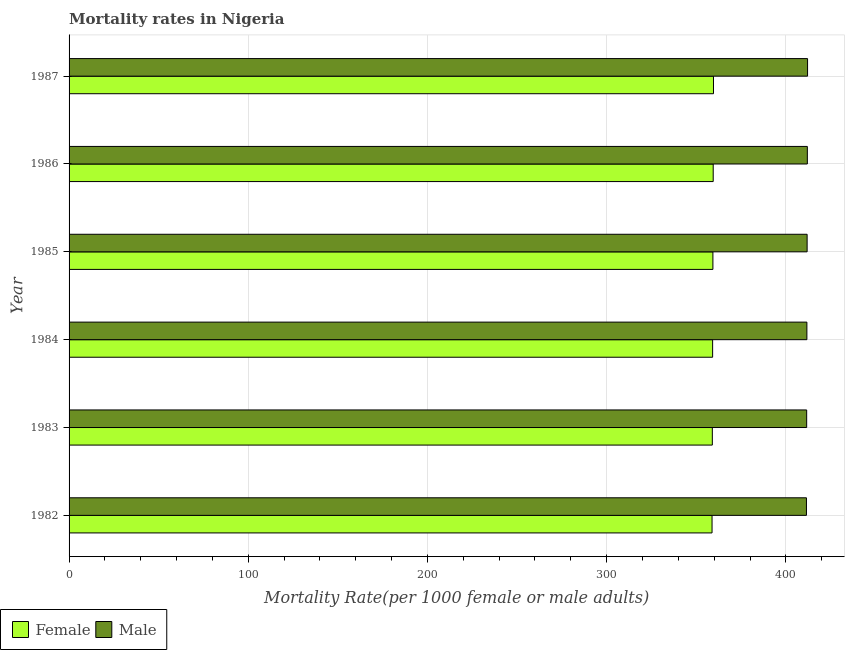How many groups of bars are there?
Keep it short and to the point. 6. Are the number of bars on each tick of the Y-axis equal?
Your response must be concise. Yes. How many bars are there on the 3rd tick from the bottom?
Ensure brevity in your answer.  2. What is the label of the 6th group of bars from the top?
Offer a terse response. 1982. In how many cases, is the number of bars for a given year not equal to the number of legend labels?
Your answer should be compact. 0. What is the female mortality rate in 1984?
Give a very brief answer. 359.14. Across all years, what is the maximum male mortality rate?
Give a very brief answer. 412.12. Across all years, what is the minimum female mortality rate?
Your answer should be very brief. 358.82. What is the total male mortality rate in the graph?
Provide a succinct answer. 2470.87. What is the difference between the male mortality rate in 1982 and that in 1983?
Make the answer very short. -0.12. What is the difference between the male mortality rate in 1985 and the female mortality rate in 1986?
Your response must be concise. 52.41. What is the average male mortality rate per year?
Provide a short and direct response. 411.81. In the year 1985, what is the difference between the female mortality rate and male mortality rate?
Make the answer very short. -52.58. In how many years, is the male mortality rate greater than 380 ?
Keep it short and to the point. 6. What is the ratio of the male mortality rate in 1982 to that in 1987?
Make the answer very short. 1. Is the female mortality rate in 1982 less than that in 1986?
Offer a terse response. Yes. Is the difference between the female mortality rate in 1985 and 1986 greater than the difference between the male mortality rate in 1985 and 1986?
Your response must be concise. No. What is the difference between the highest and the lowest male mortality rate?
Provide a short and direct response. 0.62. In how many years, is the male mortality rate greater than the average male mortality rate taken over all years?
Ensure brevity in your answer.  3. What does the 2nd bar from the top in 1983 represents?
Provide a succinct answer. Female. What does the 1st bar from the bottom in 1987 represents?
Keep it short and to the point. Female. How many bars are there?
Keep it short and to the point. 12. What is the difference between two consecutive major ticks on the X-axis?
Your response must be concise. 100. Does the graph contain any zero values?
Your answer should be compact. No. Does the graph contain grids?
Give a very brief answer. Yes. How are the legend labels stacked?
Keep it short and to the point. Horizontal. What is the title of the graph?
Offer a terse response. Mortality rates in Nigeria. What is the label or title of the X-axis?
Your answer should be very brief. Mortality Rate(per 1000 female or male adults). What is the label or title of the Y-axis?
Your answer should be very brief. Year. What is the Mortality Rate(per 1000 female or male adults) in Female in 1982?
Make the answer very short. 358.82. What is the Mortality Rate(per 1000 female or male adults) in Male in 1982?
Give a very brief answer. 411.5. What is the Mortality Rate(per 1000 female or male adults) in Female in 1983?
Provide a short and direct response. 358.98. What is the Mortality Rate(per 1000 female or male adults) in Male in 1983?
Ensure brevity in your answer.  411.62. What is the Mortality Rate(per 1000 female or male adults) in Female in 1984?
Make the answer very short. 359.14. What is the Mortality Rate(per 1000 female or male adults) of Male in 1984?
Make the answer very short. 411.75. What is the Mortality Rate(per 1000 female or male adults) in Female in 1985?
Make the answer very short. 359.3. What is the Mortality Rate(per 1000 female or male adults) of Male in 1985?
Provide a succinct answer. 411.87. What is the Mortality Rate(per 1000 female or male adults) in Female in 1986?
Make the answer very short. 359.46. What is the Mortality Rate(per 1000 female or male adults) of Male in 1986?
Offer a terse response. 412. What is the Mortality Rate(per 1000 female or male adults) in Female in 1987?
Ensure brevity in your answer.  359.62. What is the Mortality Rate(per 1000 female or male adults) in Male in 1987?
Offer a very short reply. 412.12. Across all years, what is the maximum Mortality Rate(per 1000 female or male adults) in Female?
Your answer should be very brief. 359.62. Across all years, what is the maximum Mortality Rate(per 1000 female or male adults) in Male?
Your answer should be compact. 412.12. Across all years, what is the minimum Mortality Rate(per 1000 female or male adults) in Female?
Your answer should be very brief. 358.82. Across all years, what is the minimum Mortality Rate(per 1000 female or male adults) of Male?
Your answer should be compact. 411.5. What is the total Mortality Rate(per 1000 female or male adults) of Female in the graph?
Offer a terse response. 2155.31. What is the total Mortality Rate(per 1000 female or male adults) of Male in the graph?
Give a very brief answer. 2470.87. What is the difference between the Mortality Rate(per 1000 female or male adults) of Female in 1982 and that in 1983?
Offer a terse response. -0.16. What is the difference between the Mortality Rate(per 1000 female or male adults) in Male in 1982 and that in 1983?
Your answer should be very brief. -0.12. What is the difference between the Mortality Rate(per 1000 female or male adults) of Female in 1982 and that in 1984?
Your response must be concise. -0.32. What is the difference between the Mortality Rate(per 1000 female or male adults) of Female in 1982 and that in 1985?
Offer a very short reply. -0.48. What is the difference between the Mortality Rate(per 1000 female or male adults) in Male in 1982 and that in 1985?
Offer a very short reply. -0.37. What is the difference between the Mortality Rate(per 1000 female or male adults) in Female in 1982 and that in 1986?
Offer a terse response. -0.64. What is the difference between the Mortality Rate(per 1000 female or male adults) of Male in 1982 and that in 1986?
Give a very brief answer. -0.5. What is the difference between the Mortality Rate(per 1000 female or male adults) in Female in 1982 and that in 1987?
Your answer should be compact. -0.8. What is the difference between the Mortality Rate(per 1000 female or male adults) of Male in 1982 and that in 1987?
Keep it short and to the point. -0.62. What is the difference between the Mortality Rate(per 1000 female or male adults) in Female in 1983 and that in 1984?
Your response must be concise. -0.16. What is the difference between the Mortality Rate(per 1000 female or male adults) in Male in 1983 and that in 1984?
Offer a terse response. -0.12. What is the difference between the Mortality Rate(per 1000 female or male adults) of Female in 1983 and that in 1985?
Your answer should be very brief. -0.32. What is the difference between the Mortality Rate(per 1000 female or male adults) in Male in 1983 and that in 1985?
Offer a very short reply. -0.25. What is the difference between the Mortality Rate(per 1000 female or male adults) in Female in 1983 and that in 1986?
Keep it short and to the point. -0.48. What is the difference between the Mortality Rate(per 1000 female or male adults) of Male in 1983 and that in 1986?
Offer a very short reply. -0.37. What is the difference between the Mortality Rate(per 1000 female or male adults) of Female in 1983 and that in 1987?
Ensure brevity in your answer.  -0.64. What is the difference between the Mortality Rate(per 1000 female or male adults) in Male in 1983 and that in 1987?
Ensure brevity in your answer.  -0.5. What is the difference between the Mortality Rate(per 1000 female or male adults) in Female in 1984 and that in 1985?
Make the answer very short. -0.16. What is the difference between the Mortality Rate(per 1000 female or male adults) in Male in 1984 and that in 1985?
Provide a succinct answer. -0.12. What is the difference between the Mortality Rate(per 1000 female or male adults) in Female in 1984 and that in 1986?
Keep it short and to the point. -0.32. What is the difference between the Mortality Rate(per 1000 female or male adults) of Male in 1984 and that in 1986?
Your answer should be compact. -0.25. What is the difference between the Mortality Rate(per 1000 female or male adults) in Female in 1984 and that in 1987?
Offer a terse response. -0.48. What is the difference between the Mortality Rate(per 1000 female or male adults) of Male in 1984 and that in 1987?
Provide a succinct answer. -0.37. What is the difference between the Mortality Rate(per 1000 female or male adults) in Female in 1985 and that in 1986?
Ensure brevity in your answer.  -0.16. What is the difference between the Mortality Rate(per 1000 female or male adults) of Male in 1985 and that in 1986?
Make the answer very short. -0.12. What is the difference between the Mortality Rate(per 1000 female or male adults) in Female in 1985 and that in 1987?
Make the answer very short. -0.32. What is the difference between the Mortality Rate(per 1000 female or male adults) of Male in 1985 and that in 1987?
Your answer should be compact. -0.25. What is the difference between the Mortality Rate(per 1000 female or male adults) of Female in 1986 and that in 1987?
Make the answer very short. -0.16. What is the difference between the Mortality Rate(per 1000 female or male adults) in Male in 1986 and that in 1987?
Your answer should be compact. -0.12. What is the difference between the Mortality Rate(per 1000 female or male adults) of Female in 1982 and the Mortality Rate(per 1000 female or male adults) of Male in 1983?
Offer a very short reply. -52.81. What is the difference between the Mortality Rate(per 1000 female or male adults) in Female in 1982 and the Mortality Rate(per 1000 female or male adults) in Male in 1984?
Offer a very short reply. -52.93. What is the difference between the Mortality Rate(per 1000 female or male adults) in Female in 1982 and the Mortality Rate(per 1000 female or male adults) in Male in 1985?
Offer a very short reply. -53.06. What is the difference between the Mortality Rate(per 1000 female or male adults) of Female in 1982 and the Mortality Rate(per 1000 female or male adults) of Male in 1986?
Keep it short and to the point. -53.18. What is the difference between the Mortality Rate(per 1000 female or male adults) of Female in 1982 and the Mortality Rate(per 1000 female or male adults) of Male in 1987?
Offer a very short reply. -53.31. What is the difference between the Mortality Rate(per 1000 female or male adults) in Female in 1983 and the Mortality Rate(per 1000 female or male adults) in Male in 1984?
Give a very brief answer. -52.77. What is the difference between the Mortality Rate(per 1000 female or male adults) of Female in 1983 and the Mortality Rate(per 1000 female or male adults) of Male in 1985?
Offer a terse response. -52.9. What is the difference between the Mortality Rate(per 1000 female or male adults) in Female in 1983 and the Mortality Rate(per 1000 female or male adults) in Male in 1986?
Your response must be concise. -53.02. What is the difference between the Mortality Rate(per 1000 female or male adults) in Female in 1983 and the Mortality Rate(per 1000 female or male adults) in Male in 1987?
Offer a terse response. -53.15. What is the difference between the Mortality Rate(per 1000 female or male adults) of Female in 1984 and the Mortality Rate(per 1000 female or male adults) of Male in 1985?
Ensure brevity in your answer.  -52.74. What is the difference between the Mortality Rate(per 1000 female or male adults) of Female in 1984 and the Mortality Rate(per 1000 female or male adults) of Male in 1986?
Your answer should be compact. -52.86. What is the difference between the Mortality Rate(per 1000 female or male adults) of Female in 1984 and the Mortality Rate(per 1000 female or male adults) of Male in 1987?
Provide a short and direct response. -52.99. What is the difference between the Mortality Rate(per 1000 female or male adults) in Female in 1985 and the Mortality Rate(per 1000 female or male adults) in Male in 1986?
Give a very brief answer. -52.7. What is the difference between the Mortality Rate(per 1000 female or male adults) in Female in 1985 and the Mortality Rate(per 1000 female or male adults) in Male in 1987?
Provide a succinct answer. -52.83. What is the difference between the Mortality Rate(per 1000 female or male adults) in Female in 1986 and the Mortality Rate(per 1000 female or male adults) in Male in 1987?
Ensure brevity in your answer.  -52.66. What is the average Mortality Rate(per 1000 female or male adults) in Female per year?
Your answer should be very brief. 359.22. What is the average Mortality Rate(per 1000 female or male adults) of Male per year?
Ensure brevity in your answer.  411.81. In the year 1982, what is the difference between the Mortality Rate(per 1000 female or male adults) of Female and Mortality Rate(per 1000 female or male adults) of Male?
Give a very brief answer. -52.68. In the year 1983, what is the difference between the Mortality Rate(per 1000 female or male adults) of Female and Mortality Rate(per 1000 female or male adults) of Male?
Offer a terse response. -52.65. In the year 1984, what is the difference between the Mortality Rate(per 1000 female or male adults) of Female and Mortality Rate(per 1000 female or male adults) of Male?
Give a very brief answer. -52.61. In the year 1985, what is the difference between the Mortality Rate(per 1000 female or male adults) of Female and Mortality Rate(per 1000 female or male adults) of Male?
Your answer should be very brief. -52.58. In the year 1986, what is the difference between the Mortality Rate(per 1000 female or male adults) of Female and Mortality Rate(per 1000 female or male adults) of Male?
Provide a succinct answer. -52.54. In the year 1987, what is the difference between the Mortality Rate(per 1000 female or male adults) in Female and Mortality Rate(per 1000 female or male adults) in Male?
Provide a succinct answer. -52.5. What is the ratio of the Mortality Rate(per 1000 female or male adults) in Female in 1982 to that in 1983?
Provide a short and direct response. 1. What is the ratio of the Mortality Rate(per 1000 female or male adults) in Male in 1982 to that in 1983?
Offer a terse response. 1. What is the ratio of the Mortality Rate(per 1000 female or male adults) of Female in 1982 to that in 1984?
Give a very brief answer. 1. What is the ratio of the Mortality Rate(per 1000 female or male adults) in Male in 1982 to that in 1984?
Provide a succinct answer. 1. What is the ratio of the Mortality Rate(per 1000 female or male adults) of Female in 1982 to that in 1986?
Ensure brevity in your answer.  1. What is the ratio of the Mortality Rate(per 1000 female or male adults) of Male in 1982 to that in 1986?
Provide a short and direct response. 1. What is the ratio of the Mortality Rate(per 1000 female or male adults) in Female in 1982 to that in 1987?
Keep it short and to the point. 1. What is the ratio of the Mortality Rate(per 1000 female or male adults) of Female in 1983 to that in 1984?
Ensure brevity in your answer.  1. What is the ratio of the Mortality Rate(per 1000 female or male adults) in Male in 1983 to that in 1986?
Your answer should be compact. 1. What is the ratio of the Mortality Rate(per 1000 female or male adults) in Female in 1983 to that in 1987?
Your answer should be compact. 1. What is the ratio of the Mortality Rate(per 1000 female or male adults) of Male in 1983 to that in 1987?
Make the answer very short. 1. What is the ratio of the Mortality Rate(per 1000 female or male adults) in Female in 1984 to that in 1985?
Make the answer very short. 1. What is the ratio of the Mortality Rate(per 1000 female or male adults) in Female in 1984 to that in 1986?
Ensure brevity in your answer.  1. What is the ratio of the Mortality Rate(per 1000 female or male adults) of Male in 1984 to that in 1986?
Make the answer very short. 1. What is the ratio of the Mortality Rate(per 1000 female or male adults) in Female in 1985 to that in 1986?
Your answer should be compact. 1. What is the ratio of the Mortality Rate(per 1000 female or male adults) of Male in 1985 to that in 1986?
Your answer should be compact. 1. What is the ratio of the Mortality Rate(per 1000 female or male adults) of Female in 1985 to that in 1987?
Keep it short and to the point. 1. What is the ratio of the Mortality Rate(per 1000 female or male adults) of Male in 1985 to that in 1987?
Give a very brief answer. 1. What is the ratio of the Mortality Rate(per 1000 female or male adults) in Female in 1986 to that in 1987?
Ensure brevity in your answer.  1. What is the difference between the highest and the second highest Mortality Rate(per 1000 female or male adults) in Female?
Keep it short and to the point. 0.16. What is the difference between the highest and the lowest Mortality Rate(per 1000 female or male adults) of Female?
Provide a succinct answer. 0.8. What is the difference between the highest and the lowest Mortality Rate(per 1000 female or male adults) in Male?
Keep it short and to the point. 0.62. 